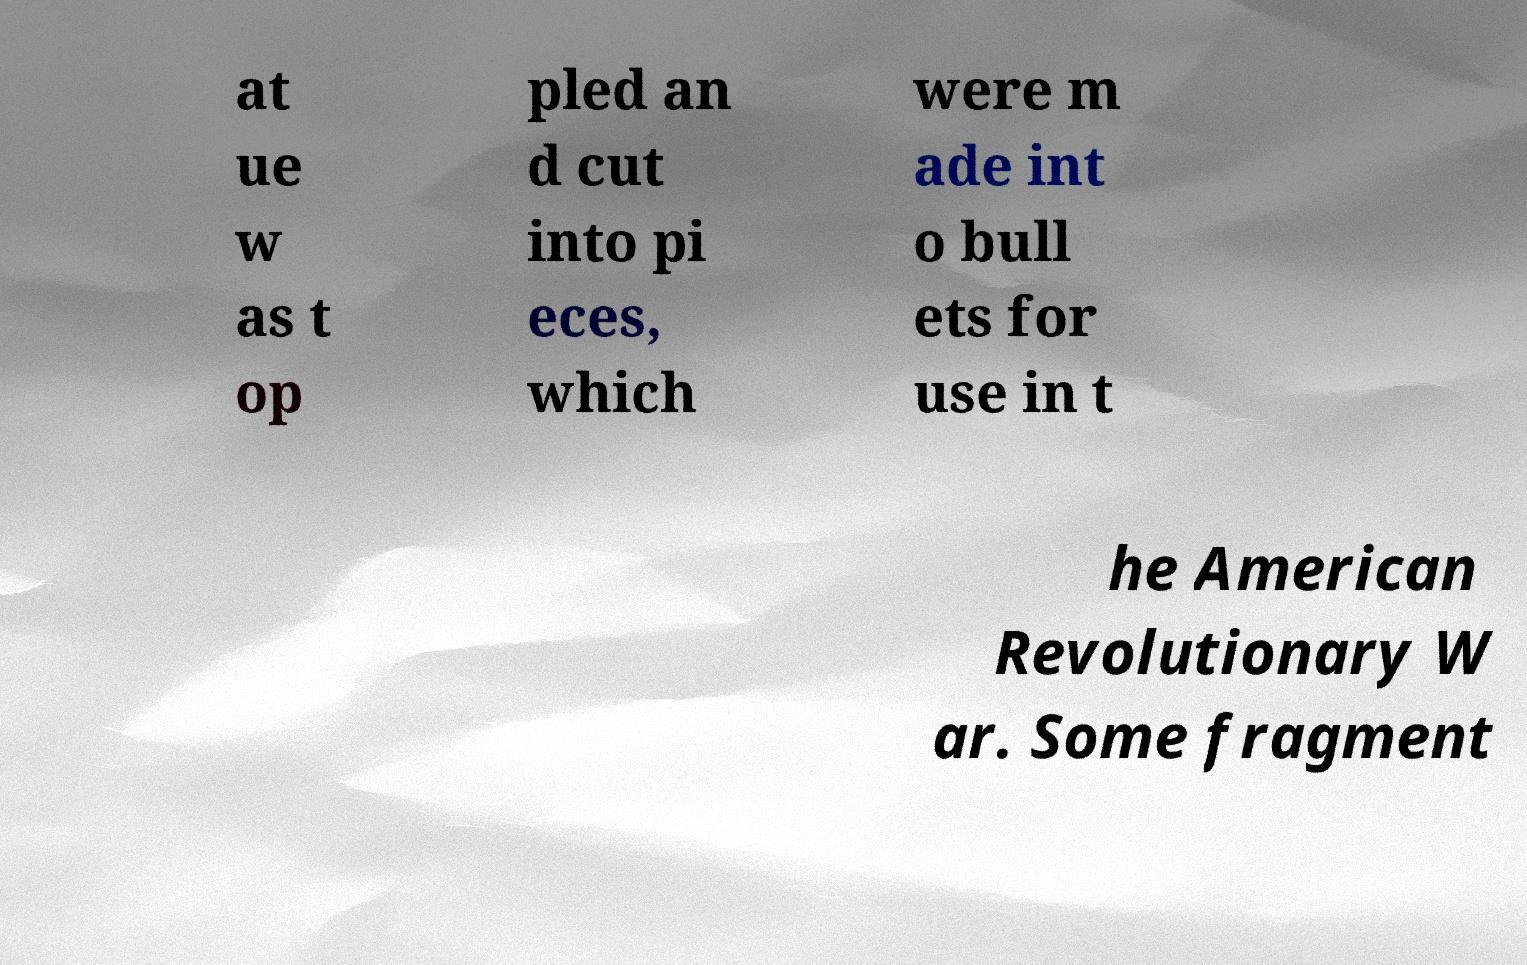Could you assist in decoding the text presented in this image and type it out clearly? at ue w as t op pled an d cut into pi eces, which were m ade int o bull ets for use in t he American Revolutionary W ar. Some fragment 